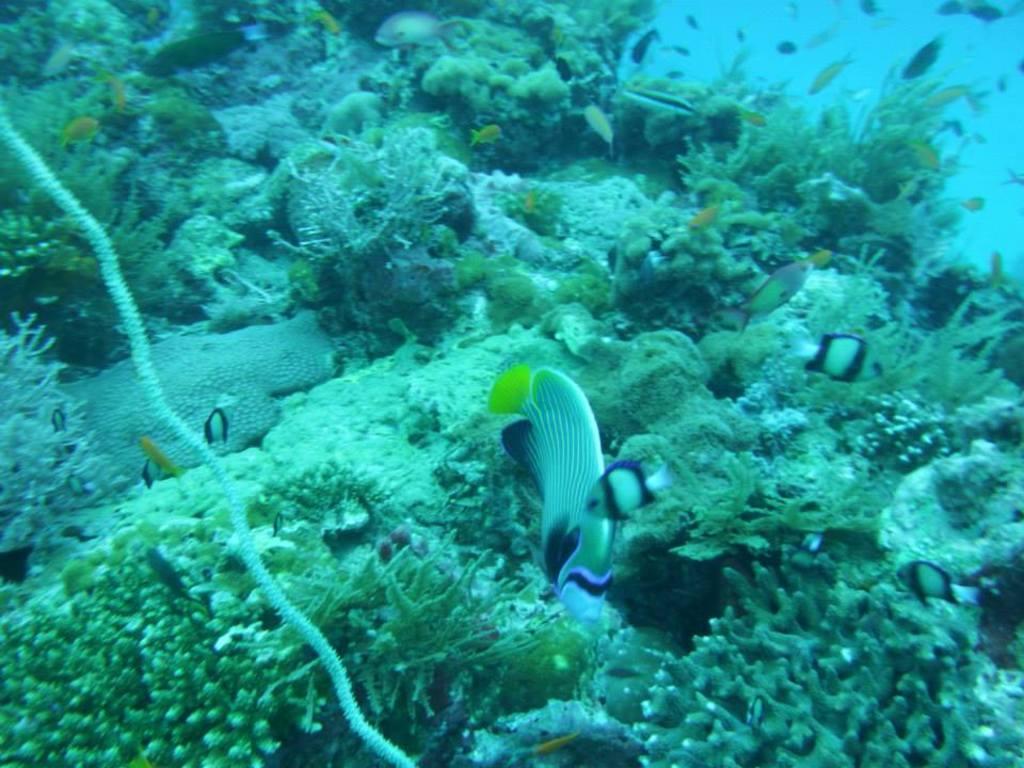Describe this image in one or two sentences. In this image we can see small fishes in the water. Here we can see small plants in the water. 